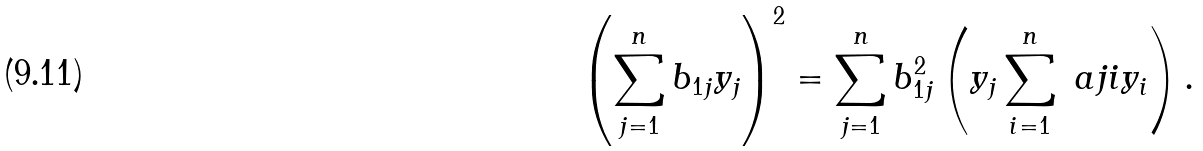Convert formula to latex. <formula><loc_0><loc_0><loc_500><loc_500>\left ( \sum _ { j = 1 } ^ { n } b _ { 1 j } y _ { j } \right ) ^ { 2 } = \sum _ { j = 1 } ^ { n } b _ { 1 j } ^ { 2 } \left ( y _ { j } \sum _ { i = 1 } ^ { n } \ a { j } { i } y _ { i } \right ) .</formula> 